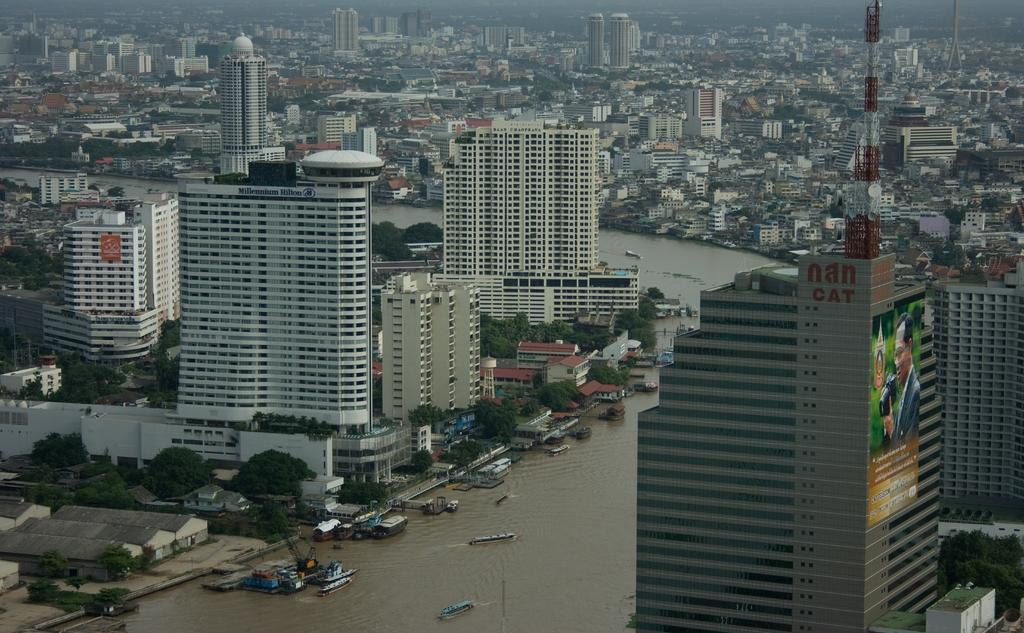What type of view is provided in the image? The image is an aerial view. What structures can be seen in the image? There are buildings, houses, and towers visible in the image. What type of natural elements are present in the image? Trees and water are present in the image. What recreational area is visible in the image? A polo field is in the image. What is visible on the ground in the image? The ground is visible in the image. What is visible at the top of the image? The sky is visible at the top of the image. What type of vest is being worn by the yak in the image? There are no yaks present in the image, and therefore no vests can be observed. 